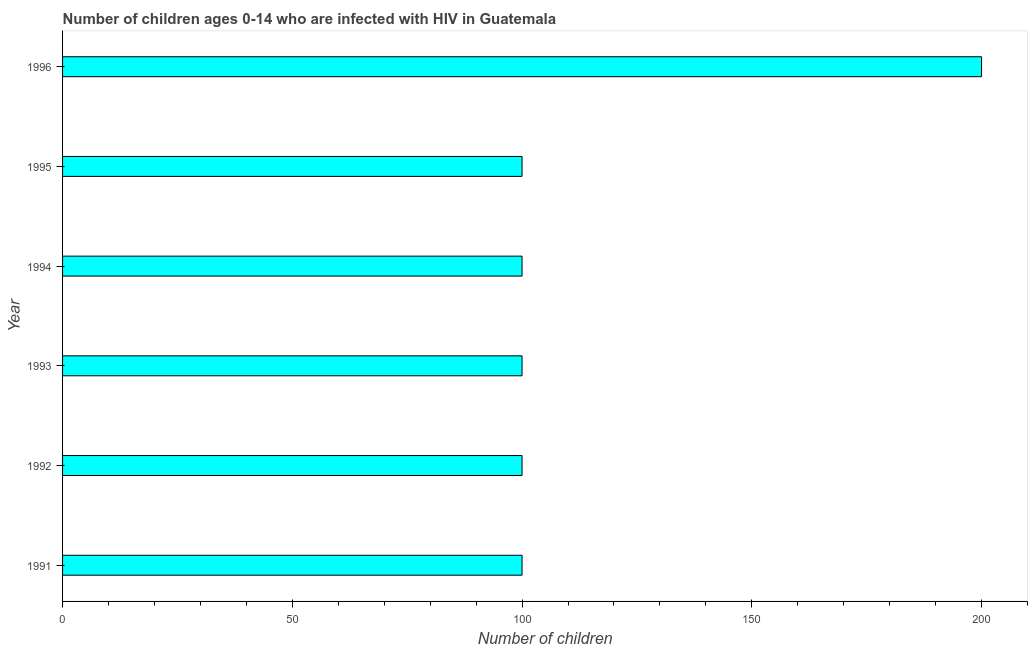Does the graph contain grids?
Provide a succinct answer. No. What is the title of the graph?
Your answer should be very brief. Number of children ages 0-14 who are infected with HIV in Guatemala. What is the label or title of the X-axis?
Provide a short and direct response. Number of children. What is the label or title of the Y-axis?
Ensure brevity in your answer.  Year. Across all years, what is the minimum number of children living with hiv?
Offer a terse response. 100. What is the sum of the number of children living with hiv?
Your answer should be very brief. 700. What is the difference between the number of children living with hiv in 1991 and 1994?
Offer a terse response. 0. What is the average number of children living with hiv per year?
Offer a very short reply. 116. In how many years, is the number of children living with hiv greater than 20 ?
Provide a short and direct response. 6. What is the difference between the highest and the second highest number of children living with hiv?
Your response must be concise. 100. What is the difference between the highest and the lowest number of children living with hiv?
Your answer should be compact. 100. How many bars are there?
Provide a succinct answer. 6. Are all the bars in the graph horizontal?
Offer a terse response. Yes. What is the difference between two consecutive major ticks on the X-axis?
Your answer should be compact. 50. What is the Number of children of 1993?
Ensure brevity in your answer.  100. What is the Number of children in 1994?
Provide a succinct answer. 100. What is the Number of children of 1996?
Provide a succinct answer. 200. What is the difference between the Number of children in 1991 and 1994?
Your answer should be compact. 0. What is the difference between the Number of children in 1991 and 1996?
Provide a short and direct response. -100. What is the difference between the Number of children in 1992 and 1993?
Your response must be concise. 0. What is the difference between the Number of children in 1992 and 1994?
Your response must be concise. 0. What is the difference between the Number of children in 1992 and 1995?
Ensure brevity in your answer.  0. What is the difference between the Number of children in 1992 and 1996?
Make the answer very short. -100. What is the difference between the Number of children in 1993 and 1996?
Provide a succinct answer. -100. What is the difference between the Number of children in 1994 and 1996?
Offer a very short reply. -100. What is the difference between the Number of children in 1995 and 1996?
Provide a short and direct response. -100. What is the ratio of the Number of children in 1991 to that in 1992?
Give a very brief answer. 1. What is the ratio of the Number of children in 1991 to that in 1993?
Provide a succinct answer. 1. What is the ratio of the Number of children in 1991 to that in 1996?
Your answer should be compact. 0.5. What is the ratio of the Number of children in 1992 to that in 1993?
Your answer should be compact. 1. What is the ratio of the Number of children in 1992 to that in 1995?
Your answer should be compact. 1. What is the ratio of the Number of children in 1994 to that in 1995?
Give a very brief answer. 1. 